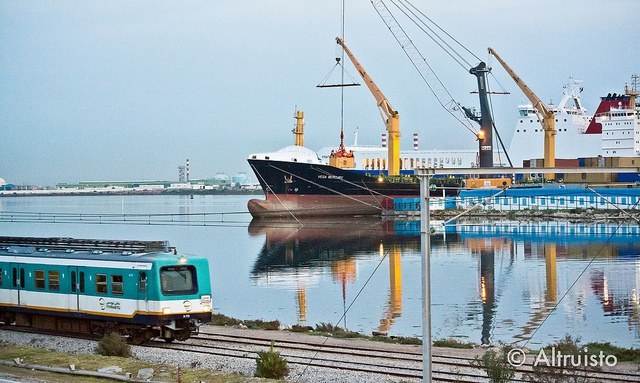Describe the objects in this image and their specific colors. I can see train in lightblue, black, teal, lightgray, and gray tones and boat in lightblue, black, gray, darkgray, and brown tones in this image. 